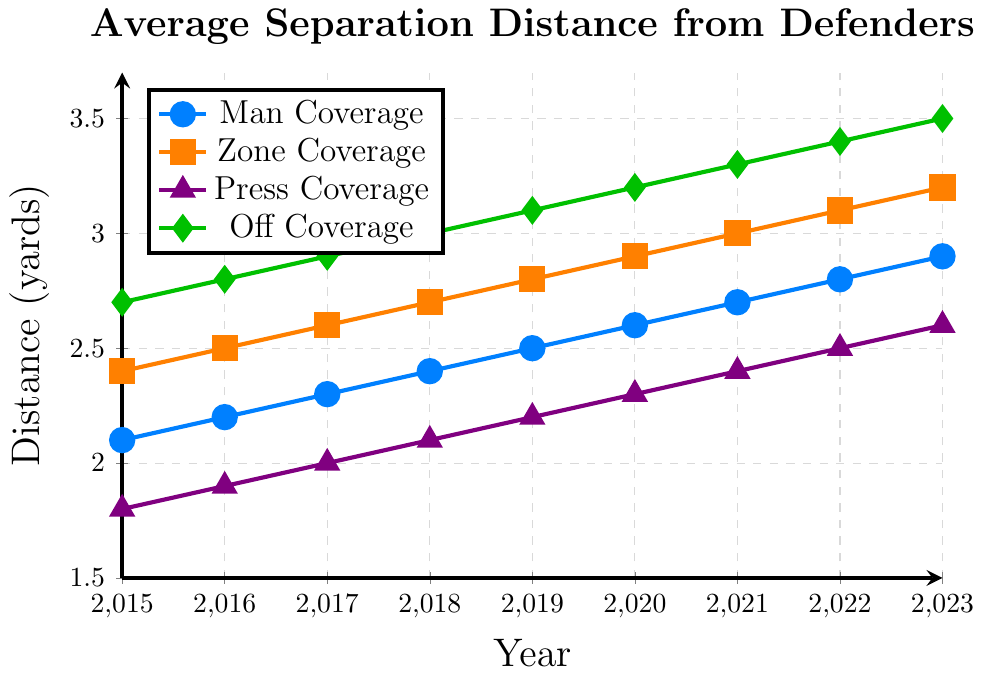what is the trend of average separation distance in man coverage from 2015 to 2023? The average separation distance in man coverage increases consistently every year from 2.1 yards in 2015 to 2.9 yards in 2023.
Answer: It increases Which coverage scheme has the highest average separation distance in 2023? By referring to the figure, off coverage has the highest value, reaching 3.5 yards in 2023.
Answer: Off coverage What's the difference in average separation distance between zone coverage and press coverage in 2020? To find the difference, subtract the average value of press coverage in 2020 (2.3 yards), from the average value of zone coverage in 2020 (2.9 yards): 2.9 - 2.3.
Answer: 0.6 yards How does the average separation distance in off coverage in 2018 compare with that in 2022? Off coverage in 2018 has a value of 3.0 yards, and in 2022 it reaches 3.4 yards. So, 3.4 - 3.0 = 0.4 yards increase.
Answer: It increased by 0.4 yards Which coverage scheme has the smallest average separation distance in 2019, and what is it? In 2019, press coverage has the smallest value with an average separation distance of 2.2 yards.
Answer: Press coverage, 2.2 yards What is the average separation distance across all coverage schemes in 2021? Sum the average separation distances for all schemes in 2021 (2.7 + 3.0 + 2.4 + 3.3) = 11.4, then divide by 4 (number of schemes): 11.4 / 4 = 2.85 yards.
Answer: 2.85 yards By how much did the average separation distance in man coverage increase from 2017 to 2023? The value for 2017 is 2.3 yards and for 2023 is 2.9 yards; subtract the two values: 2.9 - 2.3 = 0.6 yards.
Answer: 0.6 yards Which two coverage schemes have the closest average separation distances in 2016? Man coverage is at 2.2 yards and Press coverage is at 1.9 yards, whereas Zone and Off Coverage have respective distances of 2.5 and 2.8. The smallest difference is between Man and Press: 2.2 - 1.9 = 0.3 yards.
Answer: Man and Press coverage What pattern can be observed in the average separation distance in press coverage from 2015 to 2023? The separation distance incrementally rises by 0.1 yards each year starting from 1.8 yards in 2015 to 2.6 yards in 2023.
Answer: It consistently increases by 0.1 yards each year Is the average separation distance generally higher in zone coverage or man coverage? By comparing the values year by year, zone coverage has consistently higher separation distances than man coverage.
Answer: Zone coverage 